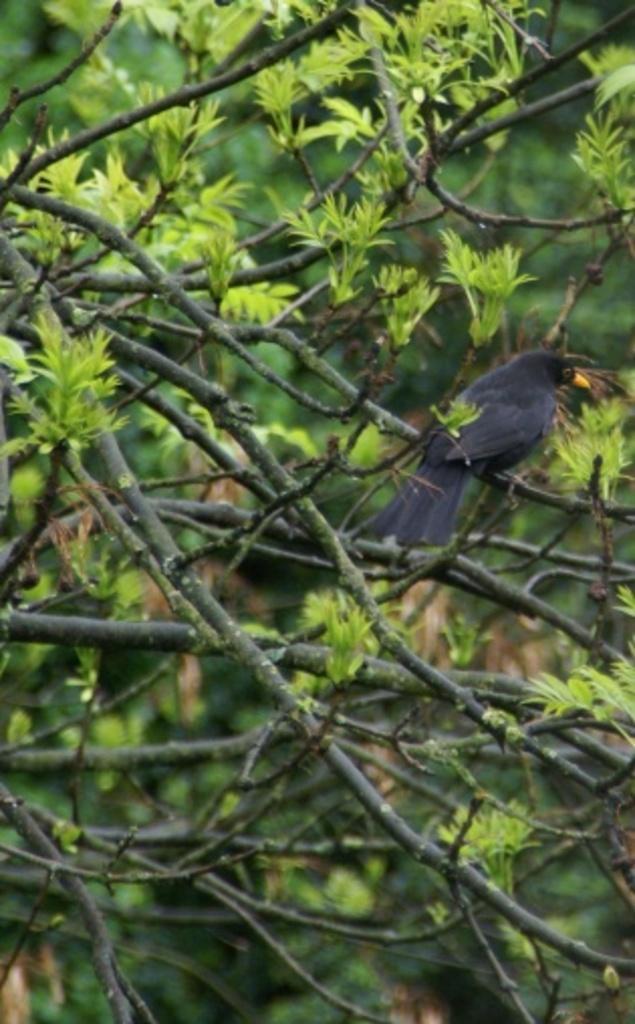Please provide a concise description of this image. In this given image, We can see few trees and crow sitting on a stem of tree, leaves. 